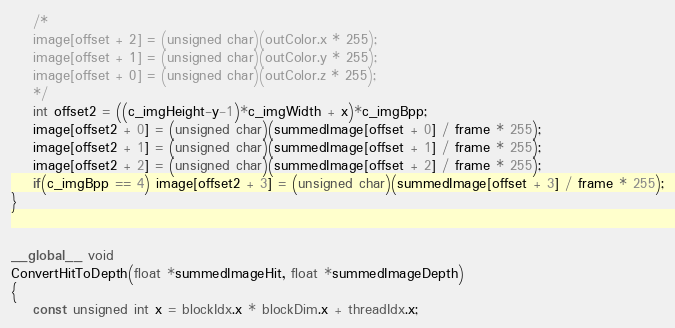Convert code to text. <code><loc_0><loc_0><loc_500><loc_500><_Cuda_>	/*
	image[offset + 2] = (unsigned char)(outColor.x * 255);
	image[offset + 1] = (unsigned char)(outColor.y * 255);
	image[offset + 0] = (unsigned char)(outColor.z * 255);
	*/
	int offset2 = ((c_imgHeight-y-1)*c_imgWidth + x)*c_imgBpp;
	image[offset2 + 0] = (unsigned char)(summedImage[offset + 0] / frame * 255);
	image[offset2 + 1] = (unsigned char)(summedImage[offset + 1] / frame * 255);
	image[offset2 + 2] = (unsigned char)(summedImage[offset + 2] / frame * 255);
	if(c_imgBpp == 4) image[offset2 + 3] = (unsigned char)(summedImage[offset + 3] / frame * 255);
}


__global__ void
ConvertHitToDepth(float *summedImageHit, float *summedImageDepth)
{
	const unsigned int x = blockIdx.x * blockDim.x + threadIdx.x;</code> 